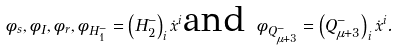Convert formula to latex. <formula><loc_0><loc_0><loc_500><loc_500>\phi _ { s } , \phi _ { I } , \phi _ { r } , \phi _ { H _ { 1 } ^ { - } } = \left ( H _ { 2 } ^ { - } \right ) _ { i } \dot { x } ^ { i } \text {and } \phi _ { Q _ { \mu + 3 } ^ { - } } = \left ( Q _ { \mu + 3 } ^ { - } \right ) _ { i } \dot { x } ^ { i } .</formula> 